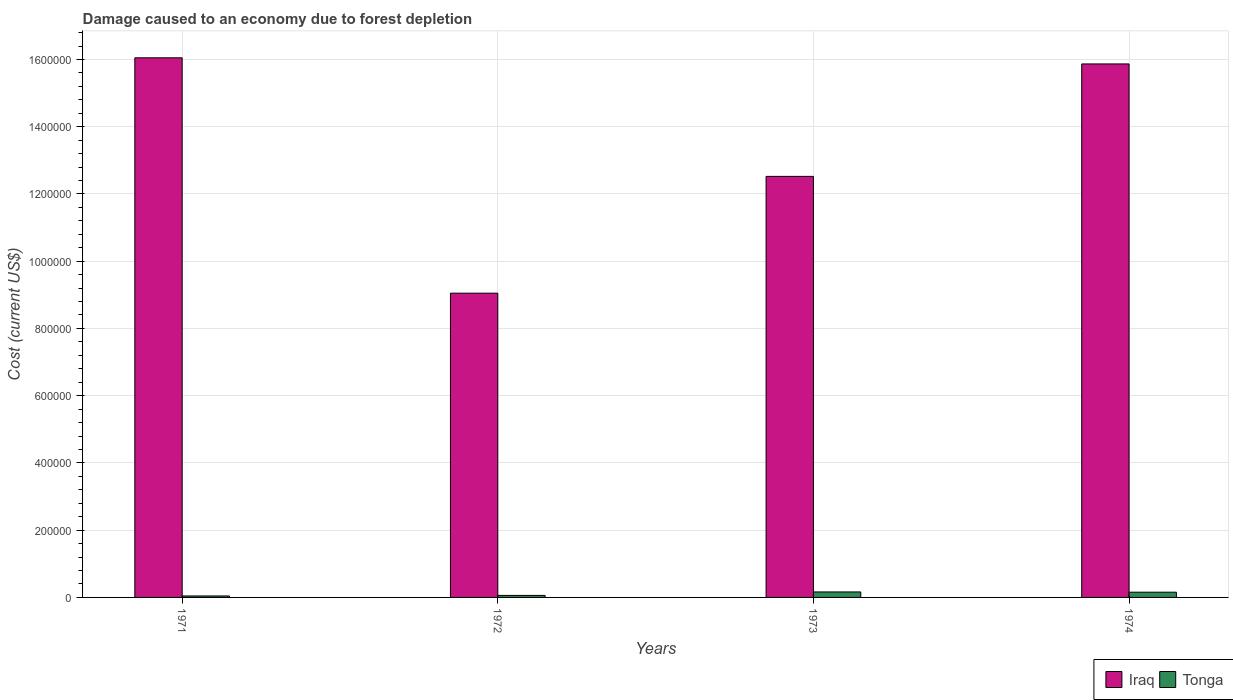How many groups of bars are there?
Offer a terse response. 4. Are the number of bars per tick equal to the number of legend labels?
Your answer should be compact. Yes. Are the number of bars on each tick of the X-axis equal?
Keep it short and to the point. Yes. How many bars are there on the 4th tick from the right?
Your answer should be very brief. 2. What is the label of the 4th group of bars from the left?
Offer a very short reply. 1974. What is the cost of damage caused due to forest depletion in Iraq in 1971?
Offer a very short reply. 1.60e+06. Across all years, what is the maximum cost of damage caused due to forest depletion in Tonga?
Ensure brevity in your answer.  1.63e+04. Across all years, what is the minimum cost of damage caused due to forest depletion in Tonga?
Make the answer very short. 4376.43. In which year was the cost of damage caused due to forest depletion in Iraq maximum?
Your answer should be compact. 1971. In which year was the cost of damage caused due to forest depletion in Iraq minimum?
Ensure brevity in your answer.  1972. What is the total cost of damage caused due to forest depletion in Iraq in the graph?
Provide a succinct answer. 5.35e+06. What is the difference between the cost of damage caused due to forest depletion in Tonga in 1973 and that in 1974?
Your response must be concise. 773.06. What is the difference between the cost of damage caused due to forest depletion in Tonga in 1974 and the cost of damage caused due to forest depletion in Iraq in 1971?
Keep it short and to the point. -1.59e+06. What is the average cost of damage caused due to forest depletion in Tonga per year?
Provide a short and direct response. 1.06e+04. In the year 1971, what is the difference between the cost of damage caused due to forest depletion in Iraq and cost of damage caused due to forest depletion in Tonga?
Provide a succinct answer. 1.60e+06. In how many years, is the cost of damage caused due to forest depletion in Tonga greater than 400000 US$?
Your response must be concise. 0. What is the ratio of the cost of damage caused due to forest depletion in Tonga in 1972 to that in 1974?
Your response must be concise. 0.39. Is the cost of damage caused due to forest depletion in Tonga in 1973 less than that in 1974?
Provide a short and direct response. No. What is the difference between the highest and the second highest cost of damage caused due to forest depletion in Tonga?
Ensure brevity in your answer.  773.06. What is the difference between the highest and the lowest cost of damage caused due to forest depletion in Tonga?
Your answer should be compact. 1.19e+04. In how many years, is the cost of damage caused due to forest depletion in Iraq greater than the average cost of damage caused due to forest depletion in Iraq taken over all years?
Your answer should be compact. 2. What does the 1st bar from the left in 1972 represents?
Keep it short and to the point. Iraq. What does the 2nd bar from the right in 1973 represents?
Ensure brevity in your answer.  Iraq. Are all the bars in the graph horizontal?
Provide a short and direct response. No. What is the difference between two consecutive major ticks on the Y-axis?
Provide a short and direct response. 2.00e+05. Where does the legend appear in the graph?
Make the answer very short. Bottom right. What is the title of the graph?
Keep it short and to the point. Damage caused to an economy due to forest depletion. Does "Iraq" appear as one of the legend labels in the graph?
Keep it short and to the point. Yes. What is the label or title of the Y-axis?
Make the answer very short. Cost (current US$). What is the Cost (current US$) in Iraq in 1971?
Offer a very short reply. 1.60e+06. What is the Cost (current US$) in Tonga in 1971?
Ensure brevity in your answer.  4376.43. What is the Cost (current US$) in Iraq in 1972?
Provide a short and direct response. 9.05e+05. What is the Cost (current US$) of Tonga in 1972?
Offer a very short reply. 5990.05. What is the Cost (current US$) of Iraq in 1973?
Offer a very short reply. 1.25e+06. What is the Cost (current US$) of Tonga in 1973?
Your response must be concise. 1.63e+04. What is the Cost (current US$) in Iraq in 1974?
Keep it short and to the point. 1.59e+06. What is the Cost (current US$) in Tonga in 1974?
Offer a terse response. 1.55e+04. Across all years, what is the maximum Cost (current US$) of Iraq?
Your response must be concise. 1.60e+06. Across all years, what is the maximum Cost (current US$) of Tonga?
Provide a short and direct response. 1.63e+04. Across all years, what is the minimum Cost (current US$) in Iraq?
Ensure brevity in your answer.  9.05e+05. Across all years, what is the minimum Cost (current US$) of Tonga?
Offer a terse response. 4376.43. What is the total Cost (current US$) in Iraq in the graph?
Your answer should be very brief. 5.35e+06. What is the total Cost (current US$) of Tonga in the graph?
Your answer should be compact. 4.22e+04. What is the difference between the Cost (current US$) in Iraq in 1971 and that in 1972?
Your answer should be compact. 7.00e+05. What is the difference between the Cost (current US$) of Tonga in 1971 and that in 1972?
Offer a terse response. -1613.61. What is the difference between the Cost (current US$) of Iraq in 1971 and that in 1973?
Ensure brevity in your answer.  3.53e+05. What is the difference between the Cost (current US$) in Tonga in 1971 and that in 1973?
Make the answer very short. -1.19e+04. What is the difference between the Cost (current US$) of Iraq in 1971 and that in 1974?
Your response must be concise. 1.82e+04. What is the difference between the Cost (current US$) in Tonga in 1971 and that in 1974?
Your response must be concise. -1.12e+04. What is the difference between the Cost (current US$) of Iraq in 1972 and that in 1973?
Make the answer very short. -3.47e+05. What is the difference between the Cost (current US$) of Tonga in 1972 and that in 1973?
Give a very brief answer. -1.03e+04. What is the difference between the Cost (current US$) in Iraq in 1972 and that in 1974?
Keep it short and to the point. -6.82e+05. What is the difference between the Cost (current US$) of Tonga in 1972 and that in 1974?
Your answer should be very brief. -9546.95. What is the difference between the Cost (current US$) of Iraq in 1973 and that in 1974?
Your answer should be very brief. -3.34e+05. What is the difference between the Cost (current US$) of Tonga in 1973 and that in 1974?
Offer a terse response. 773.06. What is the difference between the Cost (current US$) in Iraq in 1971 and the Cost (current US$) in Tonga in 1972?
Offer a very short reply. 1.60e+06. What is the difference between the Cost (current US$) of Iraq in 1971 and the Cost (current US$) of Tonga in 1973?
Ensure brevity in your answer.  1.59e+06. What is the difference between the Cost (current US$) of Iraq in 1971 and the Cost (current US$) of Tonga in 1974?
Provide a succinct answer. 1.59e+06. What is the difference between the Cost (current US$) in Iraq in 1972 and the Cost (current US$) in Tonga in 1973?
Your answer should be compact. 8.89e+05. What is the difference between the Cost (current US$) of Iraq in 1972 and the Cost (current US$) of Tonga in 1974?
Ensure brevity in your answer.  8.89e+05. What is the difference between the Cost (current US$) in Iraq in 1973 and the Cost (current US$) in Tonga in 1974?
Your answer should be very brief. 1.24e+06. What is the average Cost (current US$) in Iraq per year?
Offer a very short reply. 1.34e+06. What is the average Cost (current US$) in Tonga per year?
Provide a succinct answer. 1.06e+04. In the year 1971, what is the difference between the Cost (current US$) in Iraq and Cost (current US$) in Tonga?
Ensure brevity in your answer.  1.60e+06. In the year 1972, what is the difference between the Cost (current US$) in Iraq and Cost (current US$) in Tonga?
Provide a succinct answer. 8.99e+05. In the year 1973, what is the difference between the Cost (current US$) of Iraq and Cost (current US$) of Tonga?
Your answer should be very brief. 1.24e+06. In the year 1974, what is the difference between the Cost (current US$) of Iraq and Cost (current US$) of Tonga?
Offer a terse response. 1.57e+06. What is the ratio of the Cost (current US$) of Iraq in 1971 to that in 1972?
Keep it short and to the point. 1.77. What is the ratio of the Cost (current US$) of Tonga in 1971 to that in 1972?
Offer a very short reply. 0.73. What is the ratio of the Cost (current US$) of Iraq in 1971 to that in 1973?
Your answer should be compact. 1.28. What is the ratio of the Cost (current US$) in Tonga in 1971 to that in 1973?
Your response must be concise. 0.27. What is the ratio of the Cost (current US$) in Iraq in 1971 to that in 1974?
Provide a short and direct response. 1.01. What is the ratio of the Cost (current US$) of Tonga in 1971 to that in 1974?
Offer a terse response. 0.28. What is the ratio of the Cost (current US$) of Iraq in 1972 to that in 1973?
Provide a short and direct response. 0.72. What is the ratio of the Cost (current US$) of Tonga in 1972 to that in 1973?
Provide a succinct answer. 0.37. What is the ratio of the Cost (current US$) of Iraq in 1972 to that in 1974?
Ensure brevity in your answer.  0.57. What is the ratio of the Cost (current US$) in Tonga in 1972 to that in 1974?
Your answer should be compact. 0.39. What is the ratio of the Cost (current US$) in Iraq in 1973 to that in 1974?
Ensure brevity in your answer.  0.79. What is the ratio of the Cost (current US$) in Tonga in 1973 to that in 1974?
Your answer should be very brief. 1.05. What is the difference between the highest and the second highest Cost (current US$) in Iraq?
Make the answer very short. 1.82e+04. What is the difference between the highest and the second highest Cost (current US$) in Tonga?
Offer a very short reply. 773.06. What is the difference between the highest and the lowest Cost (current US$) in Iraq?
Your answer should be very brief. 7.00e+05. What is the difference between the highest and the lowest Cost (current US$) in Tonga?
Your answer should be very brief. 1.19e+04. 